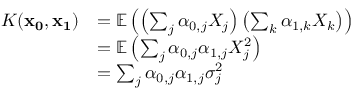<formula> <loc_0><loc_0><loc_500><loc_500>\begin{array} { r l } { K ( x _ { 0 } , x _ { 1 } ) } & { = \mathbb { E } \left ( \left ( \sum _ { j } \alpha _ { 0 , j } X _ { j } \right ) \left ( \sum _ { k } \alpha _ { 1 , k } X _ { k } \right ) \right ) } \\ & { = \mathbb { E } \left ( \sum _ { j } \alpha _ { 0 , j } \alpha _ { 1 , j } X _ { j } ^ { 2 } \right ) } \\ & { = \sum _ { j } \alpha _ { 0 , j } \alpha _ { 1 , j } \sigma _ { j } ^ { 2 } } \end{array}</formula> 